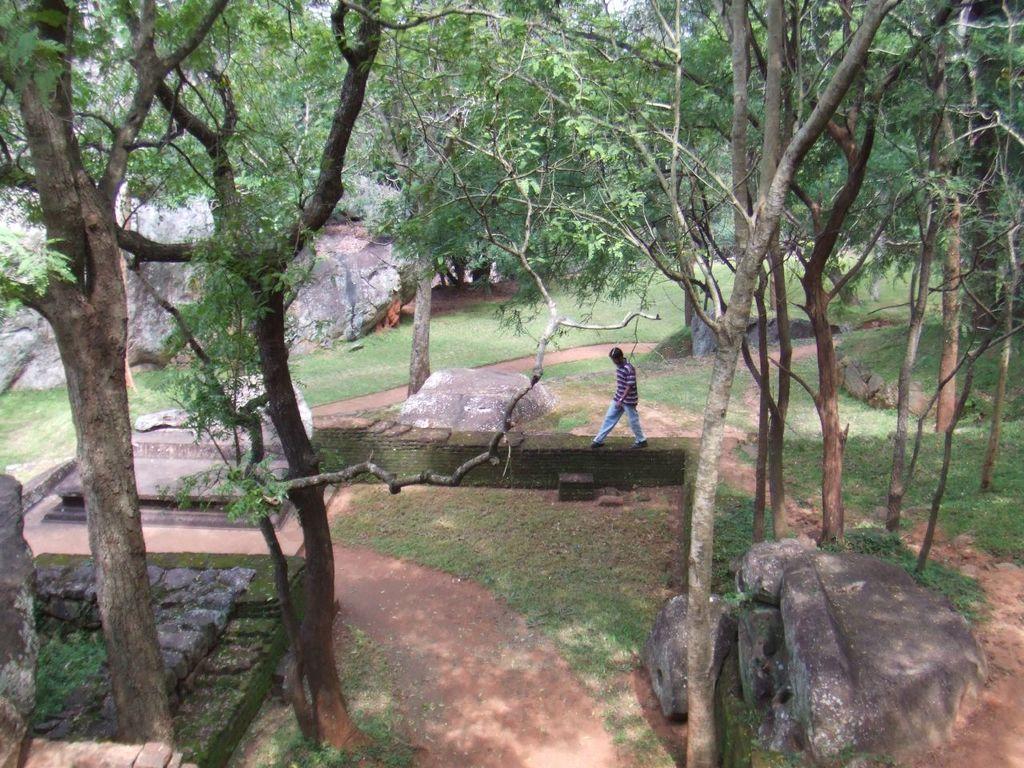In one or two sentences, can you explain what this image depicts? In this image we can see a person walking. We can also see some trees, bark of the trees, grass, rock, stones and the sky. 